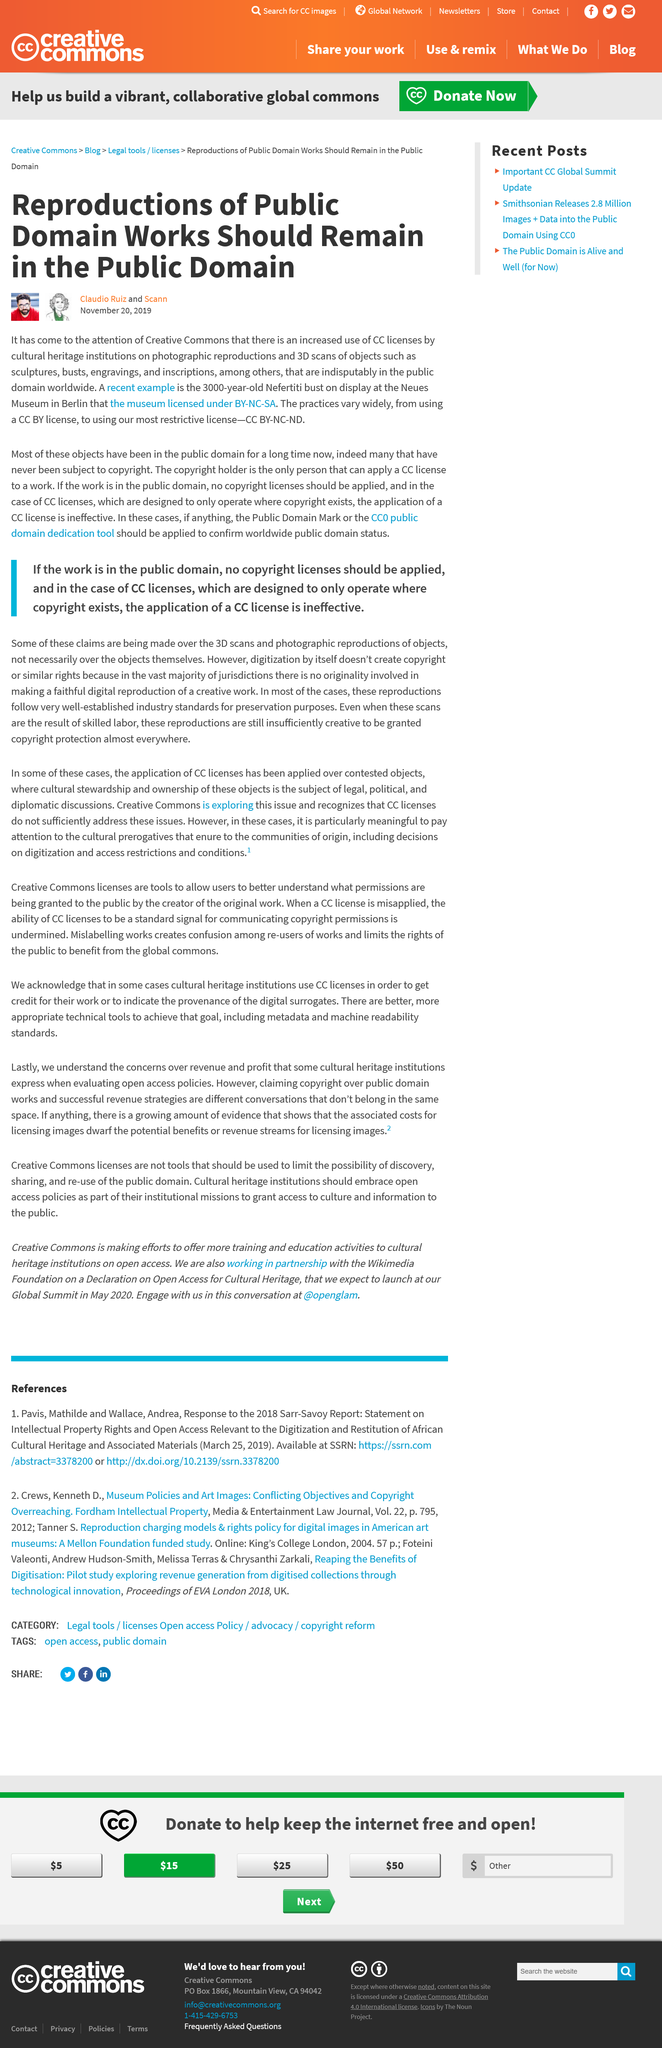Outline some significant characteristics in this image. The subjects of reproductions of public domain works were reported on by Claudio Ruiz and Scann. The CC BY-NC-ND license is considered the most restrictive license because it allows for the use of a work only for non-commercial purposes and does not allow for modifications or derivative works to be distributed. The Neues Museum in Berlin exhibited a 3000-year-old Nefertiti bust, which was a significant artifact. 